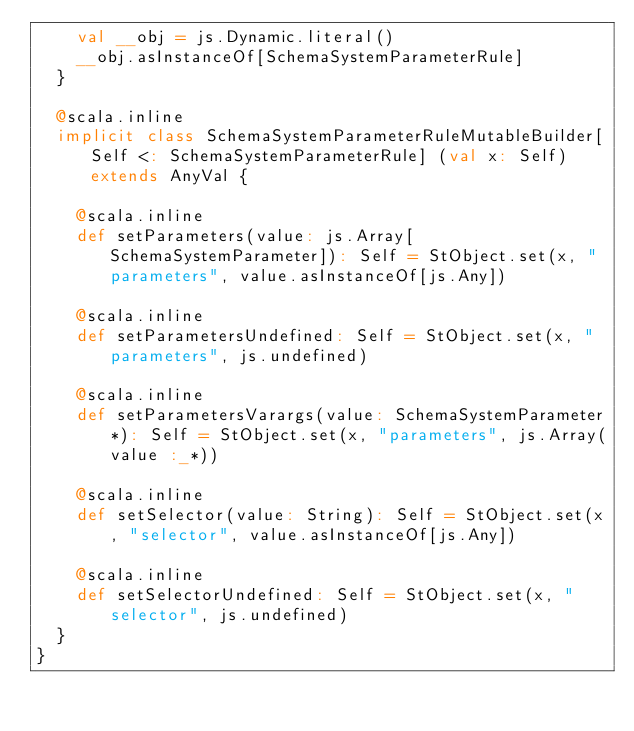<code> <loc_0><loc_0><loc_500><loc_500><_Scala_>    val __obj = js.Dynamic.literal()
    __obj.asInstanceOf[SchemaSystemParameterRule]
  }
  
  @scala.inline
  implicit class SchemaSystemParameterRuleMutableBuilder[Self <: SchemaSystemParameterRule] (val x: Self) extends AnyVal {
    
    @scala.inline
    def setParameters(value: js.Array[SchemaSystemParameter]): Self = StObject.set(x, "parameters", value.asInstanceOf[js.Any])
    
    @scala.inline
    def setParametersUndefined: Self = StObject.set(x, "parameters", js.undefined)
    
    @scala.inline
    def setParametersVarargs(value: SchemaSystemParameter*): Self = StObject.set(x, "parameters", js.Array(value :_*))
    
    @scala.inline
    def setSelector(value: String): Self = StObject.set(x, "selector", value.asInstanceOf[js.Any])
    
    @scala.inline
    def setSelectorUndefined: Self = StObject.set(x, "selector", js.undefined)
  }
}
</code> 